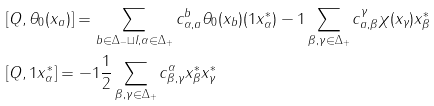Convert formula to latex. <formula><loc_0><loc_0><loc_500><loc_500>& [ Q , \theta _ { 0 } ( x _ { a } ) ] = \sum _ { b \in \Delta _ { - } \sqcup I , \alpha \in \Delta _ { + } } c _ { \alpha , a } ^ { b } \theta _ { 0 } ( x _ { b } ) ( 1 x _ { \alpha } ^ { * } ) - 1 \sum _ { \beta , \gamma \in \Delta _ { + } } c _ { a , \beta } ^ { \gamma } \chi ( x _ { \gamma } ) x _ { \beta } ^ { * } \\ & [ Q , 1 x _ { \alpha } ^ { * } ] = - 1 \frac { 1 } { 2 } \sum _ { \beta , \gamma \in \Delta _ { + } } c _ { \beta , \gamma } ^ { \alpha } x _ { \beta } ^ { * } x _ { \gamma } ^ { * }</formula> 